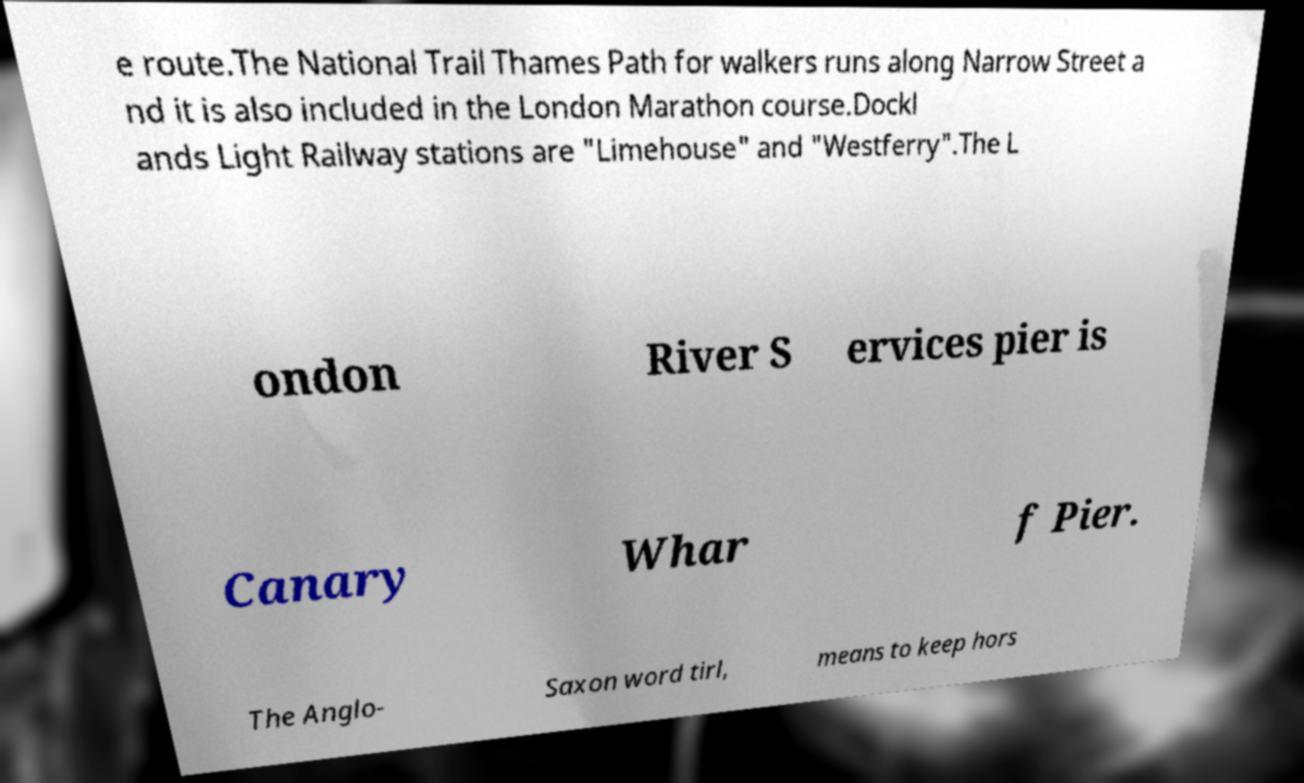Please read and relay the text visible in this image. What does it say? e route.The National Trail Thames Path for walkers runs along Narrow Street a nd it is also included in the London Marathon course.Dockl ands Light Railway stations are "Limehouse" and "Westferry".The L ondon River S ervices pier is Canary Whar f Pier. The Anglo- Saxon word tirl, means to keep hors 